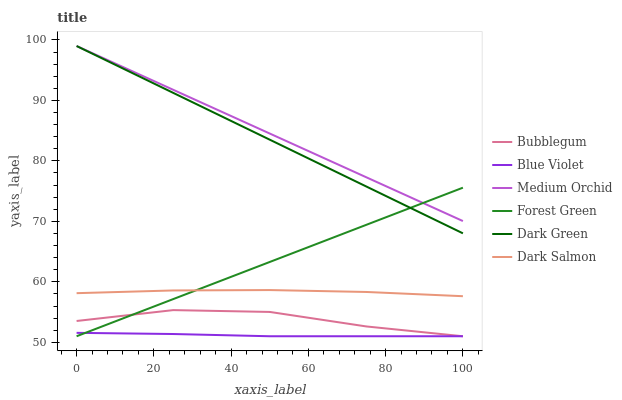Does Blue Violet have the minimum area under the curve?
Answer yes or no. Yes. Does Medium Orchid have the maximum area under the curve?
Answer yes or no. Yes. Does Dark Salmon have the minimum area under the curve?
Answer yes or no. No. Does Dark Salmon have the maximum area under the curve?
Answer yes or no. No. Is Medium Orchid the smoothest?
Answer yes or no. Yes. Is Bubblegum the roughest?
Answer yes or no. Yes. Is Dark Salmon the smoothest?
Answer yes or no. No. Is Dark Salmon the roughest?
Answer yes or no. No. Does Bubblegum have the lowest value?
Answer yes or no. Yes. Does Dark Salmon have the lowest value?
Answer yes or no. No. Does Dark Green have the highest value?
Answer yes or no. Yes. Does Dark Salmon have the highest value?
Answer yes or no. No. Is Blue Violet less than Dark Green?
Answer yes or no. Yes. Is Medium Orchid greater than Blue Violet?
Answer yes or no. Yes. Does Forest Green intersect Dark Green?
Answer yes or no. Yes. Is Forest Green less than Dark Green?
Answer yes or no. No. Is Forest Green greater than Dark Green?
Answer yes or no. No. Does Blue Violet intersect Dark Green?
Answer yes or no. No. 